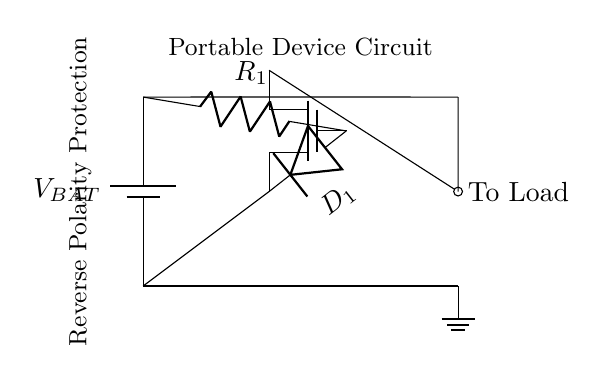What is the type of component represented by the symbol at the center? The center symbol is a N-channel MOSFET, specifically depicted as a "nmos", which is used for switching in this circuit.
Answer: N-channel MOSFET What is the purpose of the diode in this circuit? The diode serves to prevent reverse current flow, thereby protecting the circuit from damage if the battery is connected with the wrong polarity.
Answer: Prevent reverse current flow What is the label of the resistor in the circuit? The resistor is labeled as R1, which is connected to the gate of the MOSFET, playing a role in controlling the MOSFET switching.
Answer: R1 How many connections are made to the ground? There are two connections shown to the ground in the circuit diagram, one from the battery and one from the MOSFET source.
Answer: Two connections What happens if the battery is connected with the wrong polarity? If connected with the wrong polarity, the diode will block the current, preventing any flow and protecting the circuit from damage.
Answer: Current is blocked What role does the resistor play in this particular protection circuit? The resistor R1 controls the gate voltage of the MOSFET, ensuring it turns on only when the correct polarity is applied to the battery, enabling proper function and protection.
Answer: Controls gate voltage Where does the load connect in the circuit? The load connects at the output of the MOSFET, where the diode also leads to the load, ensuring that current flows correctly when the battery is connected properly.
Answer: To MOSFET output 